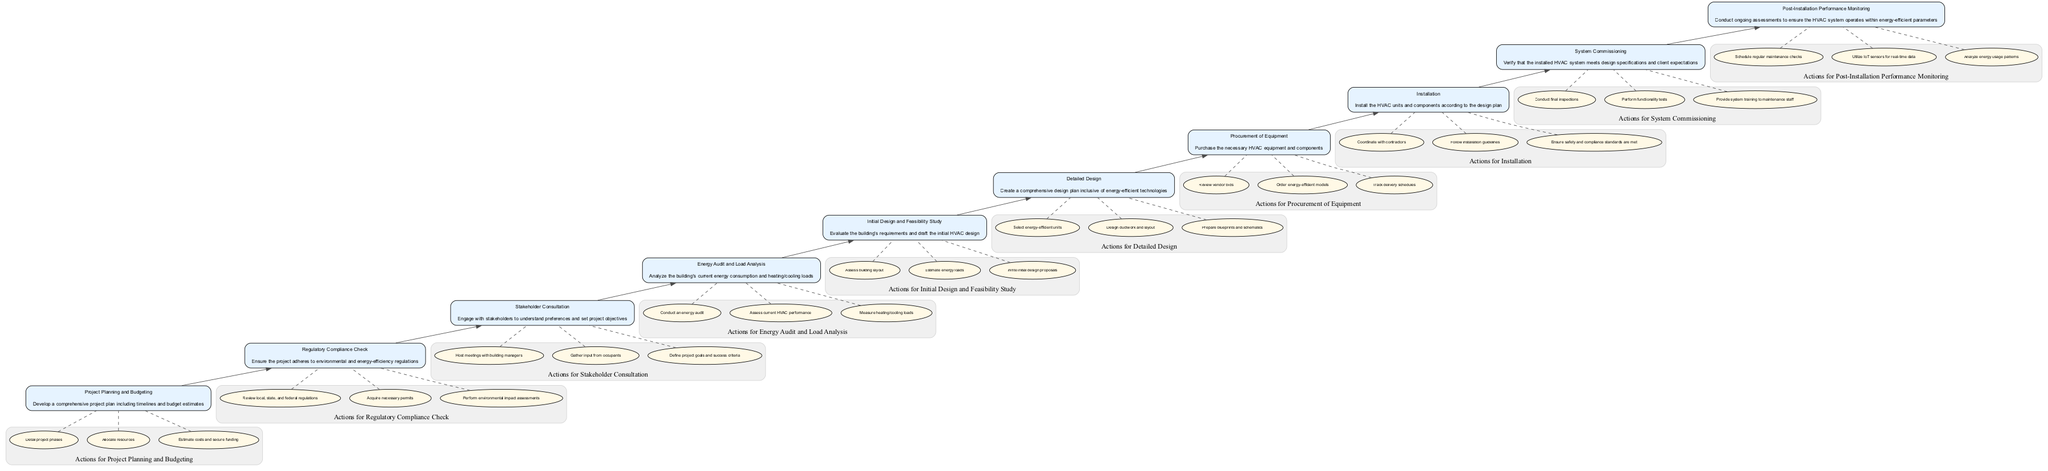What is the first step in the HVAC implementation procedure? The first step indicated in the flow chart is "Project Planning and Budgeting." This is the bottom node and serves as the foundation for all subsequent actions in the process.
Answer: Project Planning and Budgeting How many total steps are there in the procedure? By counting all the nodes in the diagram, we see there are ten steps listed, from Project Planning and Budgeting to Post-Installation Performance Monitoring.
Answer: Ten What action is associated with the "System Commissioning" step? In the diagram, the actions for the "System Commissioning" step include "Conduct final inspections," "Perform functionality tests," and "Provide system training to maintenance staff." These actions are listed under the node "System Commissioning."
Answer: Conduct final inspections, Perform functionality tests, Provide system training to maintenance staff What is the relationship between "Installation" and "Procurement of Equipment"? The relationship shown in the flow chart indicates that "Procurement of Equipment" occurs before "Installation." This means that equipment must be procured prior to the actual installation of the HVAC systems.
Answer: Procurement of Equipment occurs before Installation Which step includes "Regulatory Compliance Check"? The step "Regulatory Compliance Check" is the second node in the flow chart, meaning it is the second action that must be undertaken after "Project Planning and Budgeting."
Answer: Regulatory Compliance Check What type of actions should be conducted during the "Post-Installation Performance Monitoring" phase? This phase involves actions such as "Schedule regular maintenance checks," "Utilize IoT sensors for real-time data," and "Analyze energy usage patterns," which focus on assessing and ensuring the system's ongoing efficiency.
Answer: Schedule regular maintenance checks, Utilize IoT sensors for real-time data, Analyze energy usage patterns How does "Stakeholder Consultation" impact the project? "Stakeholder Consultation" influences the project by engaging stakeholders to understand their preferences and set the project objectives, thereby aligning the project with stakeholder expectations.
Answer: Engaging stakeholders to set project objectives Which node is directly above "Installation" in the flow chart? The node directly above "Installation" is "System Commissioning," indicating that after installation, the next phase is to verify that the system meets specifications and client expectations.
Answer: System Commissioning Which phase requires conducting an energy audit? The phase that requires an energy audit is the "Energy Audit and Load Analysis." This step focuses on analyzing the current energy consumption and determining the heating and cooling loads of the building.
Answer: Energy Audit and Load Analysis 